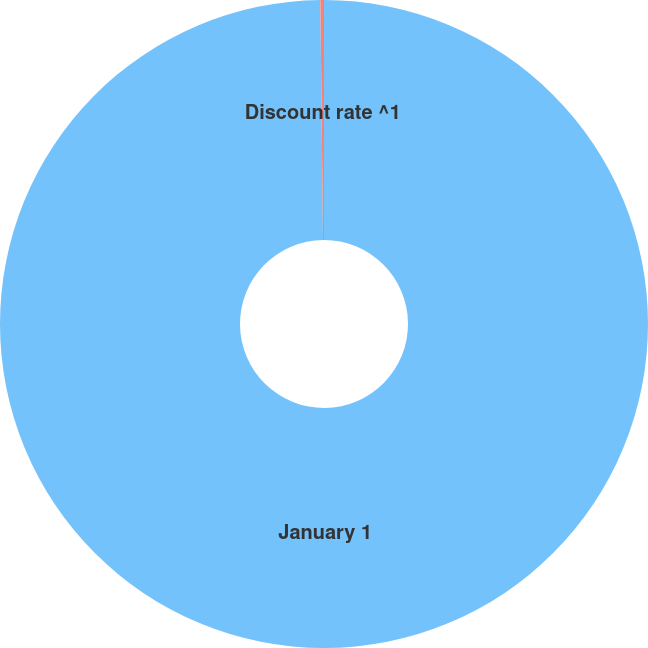Convert chart to OTSL. <chart><loc_0><loc_0><loc_500><loc_500><pie_chart><fcel>January 1<fcel>Discount rate ^1<nl><fcel>99.82%<fcel>0.18%<nl></chart> 